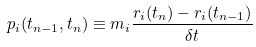<formula> <loc_0><loc_0><loc_500><loc_500>p _ { i } ( t _ { n - 1 } , t _ { n } ) \equiv m _ { i } \frac { r _ { i } ( t _ { n } ) - r _ { i } ( t _ { n - 1 } ) } { \delta t }</formula> 